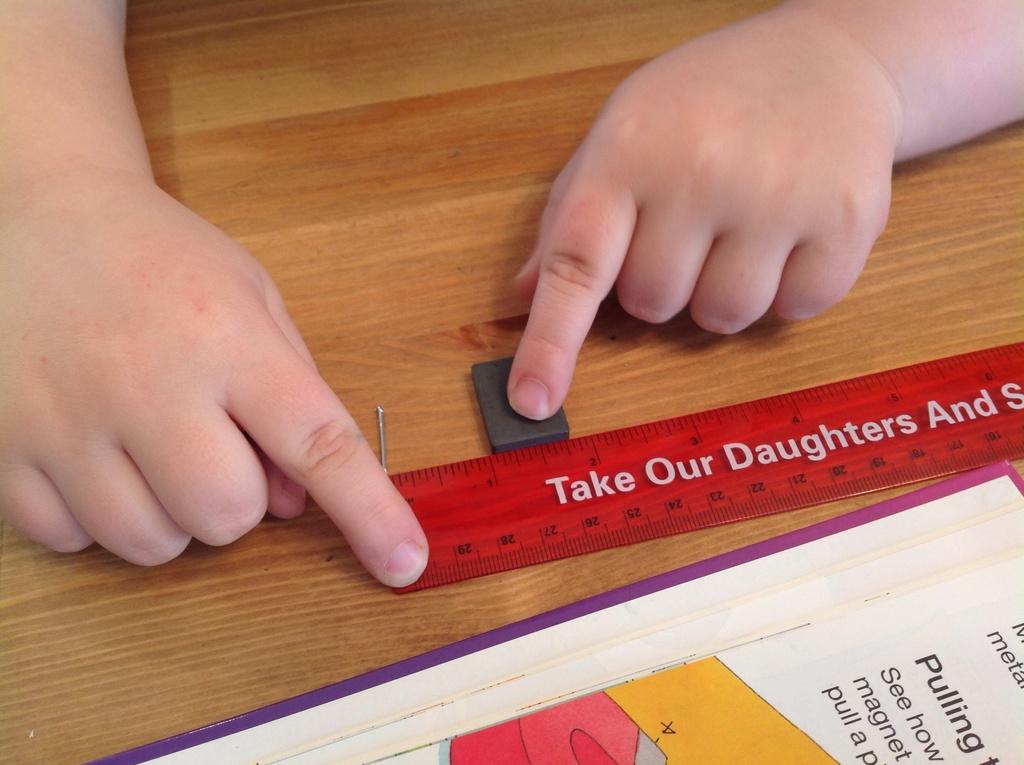What does the ruler say?
Provide a succinct answer. Take our daughters and s. 